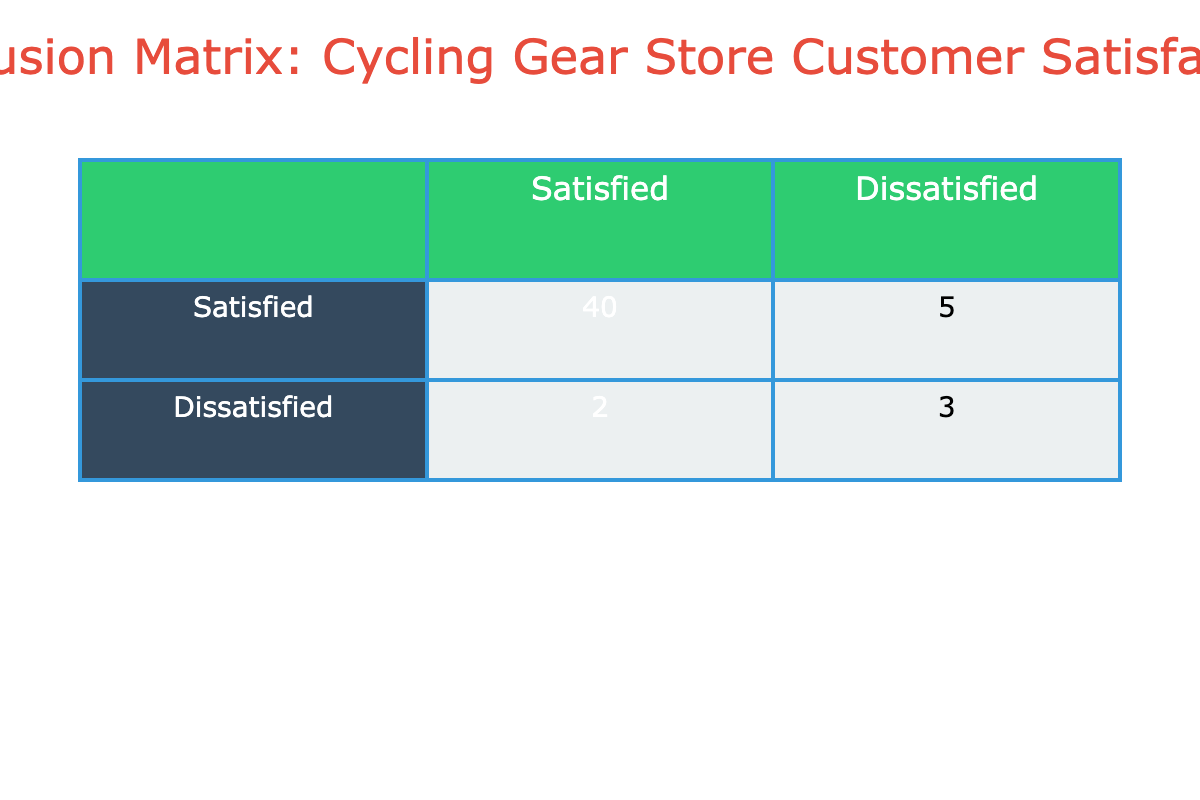What is the count of satisfied customers who predicted satisfaction? In the table, under the column "Satisfied" and the row "Satisfied," the value given is 40. This means there are 40 satisfied customers who predicted that they would be satisfied.
Answer: 40 What is the total number of dissatisfied customers? The total number of dissatisfied customers can be found by summing the values in the "Dissatisfied" row: 2 + 3 = 5. Therefore, there are 5 dissatisfied customers in total.
Answer: 5 Is it true that more customers were satisfied than dissatisfied? By comparing the values, there are 40 customers who were satisfied and only 5 who were dissatisfied. Since 40 > 5, the statement is true.
Answer: Yes What is the proportion of satisfied customers who predicted dissatisfaction? The number of customers who predicted dissatisfaction is 5, and the total number of predictions is 40 (satisfied) + 5 (dissatisfied) = 45. Thus, the proportion is 5/45, which simplifies to approximately 0.111 or 11.1%.
Answer: 11.1% What is the difference between the number of satisfied customers and dissatisfied customers? To find the difference, we look at satisfied customers (40) and dissatisfied customers (5). The difference is 40 - 5 = 35.
Answer: 35 How many customers were accurately classified as dissatisfied? The number of customers accurately classified as dissatisfied is found in the "Dissatisfied" row and "Dissatisfied" column, which is 3. This means 3 customers were accurately categorized.
Answer: 3 What is the total number of satisfied predictions made? The total number of satisfied predictions is the sum of satisfied and dissatisfied predictions in the "Satisfied" column: 40 (predicted satisfied) + 5 (predicted dissatisfied) = 45.
Answer: 45 Was the number of satisfied customers who were misclassified higher than those accurately classified? The misclassified satisfied customers, indicated by the value 5, must be compared to those accurately classified, which is 40. Therefore, 5 is not higher than 40.
Answer: No 